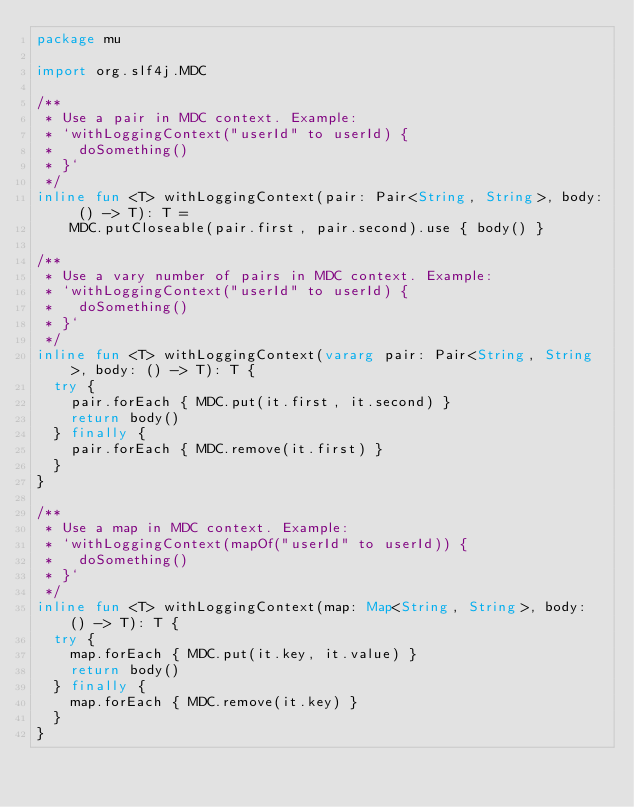<code> <loc_0><loc_0><loc_500><loc_500><_Kotlin_>package mu

import org.slf4j.MDC

/**
 * Use a pair in MDC context. Example:
 * `withLoggingContext("userId" to userId) {
 *   doSomething()
 * }`
 */
inline fun <T> withLoggingContext(pair: Pair<String, String>, body: () -> T): T =
    MDC.putCloseable(pair.first, pair.second).use { body() }

/**
 * Use a vary number of pairs in MDC context. Example:
 * `withLoggingContext("userId" to userId) {
 *   doSomething()
 * }`
 */
inline fun <T> withLoggingContext(vararg pair: Pair<String, String>, body: () -> T): T {
  try {
    pair.forEach { MDC.put(it.first, it.second) }
    return body()
  } finally {
    pair.forEach { MDC.remove(it.first) }
  }
}

/**
 * Use a map in MDC context. Example:
 * `withLoggingContext(mapOf("userId" to userId)) {
 *   doSomething()
 * }`
 */
inline fun <T> withLoggingContext(map: Map<String, String>, body: () -> T): T {
  try {
    map.forEach { MDC.put(it.key, it.value) }
    return body()
  } finally {
    map.forEach { MDC.remove(it.key) }
  }
}
</code> 